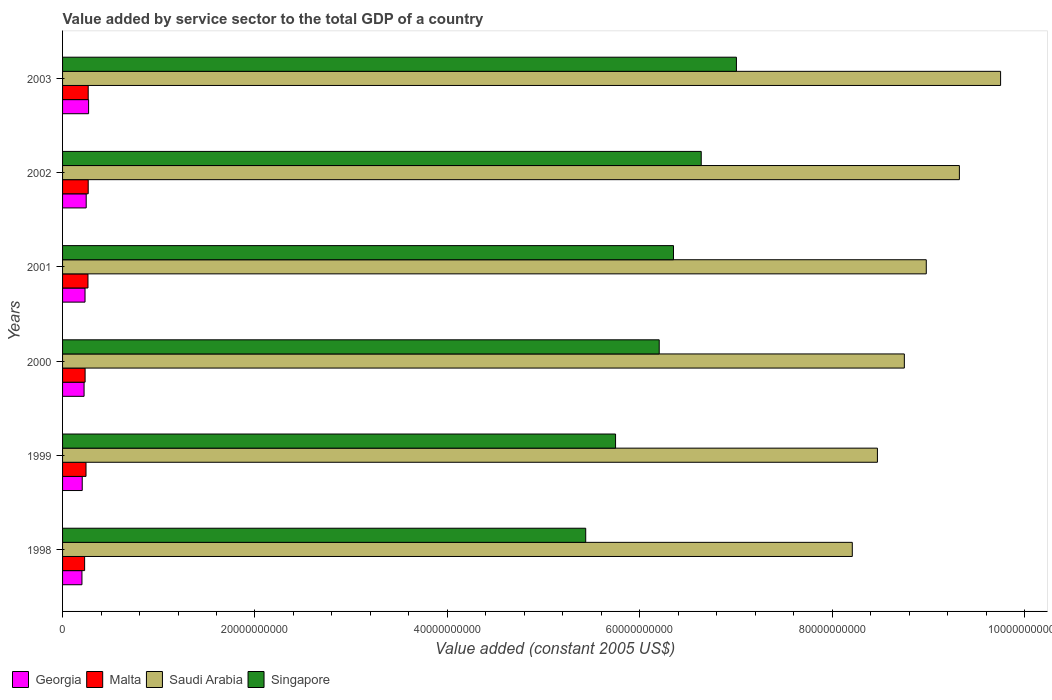How many groups of bars are there?
Your answer should be very brief. 6. Are the number of bars per tick equal to the number of legend labels?
Offer a very short reply. Yes. How many bars are there on the 1st tick from the top?
Provide a short and direct response. 4. How many bars are there on the 2nd tick from the bottom?
Offer a very short reply. 4. What is the label of the 1st group of bars from the top?
Offer a very short reply. 2003. In how many cases, is the number of bars for a given year not equal to the number of legend labels?
Offer a terse response. 0. What is the value added by service sector in Saudi Arabia in 1998?
Your answer should be compact. 8.21e+1. Across all years, what is the maximum value added by service sector in Saudi Arabia?
Make the answer very short. 9.75e+1. Across all years, what is the minimum value added by service sector in Singapore?
Provide a short and direct response. 5.44e+1. In which year was the value added by service sector in Malta minimum?
Offer a very short reply. 1998. What is the total value added by service sector in Malta in the graph?
Ensure brevity in your answer.  1.50e+1. What is the difference between the value added by service sector in Malta in 2002 and that in 2003?
Your answer should be very brief. 1.96e+05. What is the difference between the value added by service sector in Malta in 2003 and the value added by service sector in Georgia in 2002?
Your response must be concise. 2.07e+08. What is the average value added by service sector in Georgia per year?
Your answer should be compact. 2.30e+09. In the year 1999, what is the difference between the value added by service sector in Saudi Arabia and value added by service sector in Malta?
Your response must be concise. 8.23e+1. In how many years, is the value added by service sector in Malta greater than 48000000000 US$?
Give a very brief answer. 0. What is the ratio of the value added by service sector in Singapore in 2000 to that in 2003?
Provide a succinct answer. 0.89. Is the value added by service sector in Malta in 1999 less than that in 2001?
Give a very brief answer. Yes. What is the difference between the highest and the second highest value added by service sector in Georgia?
Provide a short and direct response. 2.49e+08. What is the difference between the highest and the lowest value added by service sector in Saudi Arabia?
Your answer should be very brief. 1.54e+1. In how many years, is the value added by service sector in Saudi Arabia greater than the average value added by service sector in Saudi Arabia taken over all years?
Offer a very short reply. 3. Is the sum of the value added by service sector in Singapore in 1998 and 2003 greater than the maximum value added by service sector in Saudi Arabia across all years?
Your response must be concise. Yes. What does the 4th bar from the top in 1999 represents?
Ensure brevity in your answer.  Georgia. What does the 2nd bar from the bottom in 2000 represents?
Offer a terse response. Malta. How many bars are there?
Your answer should be compact. 24. What is the difference between two consecutive major ticks on the X-axis?
Your answer should be compact. 2.00e+1. Are the values on the major ticks of X-axis written in scientific E-notation?
Offer a terse response. No. Does the graph contain any zero values?
Your answer should be very brief. No. Does the graph contain grids?
Offer a very short reply. No. Where does the legend appear in the graph?
Keep it short and to the point. Bottom left. What is the title of the graph?
Your answer should be compact. Value added by service sector to the total GDP of a country. What is the label or title of the X-axis?
Your answer should be compact. Value added (constant 2005 US$). What is the Value added (constant 2005 US$) in Georgia in 1998?
Provide a short and direct response. 2.02e+09. What is the Value added (constant 2005 US$) in Malta in 1998?
Offer a very short reply. 2.29e+09. What is the Value added (constant 2005 US$) in Saudi Arabia in 1998?
Provide a succinct answer. 8.21e+1. What is the Value added (constant 2005 US$) in Singapore in 1998?
Your response must be concise. 5.44e+1. What is the Value added (constant 2005 US$) of Georgia in 1999?
Your response must be concise. 2.04e+09. What is the Value added (constant 2005 US$) in Malta in 1999?
Your answer should be very brief. 2.44e+09. What is the Value added (constant 2005 US$) in Saudi Arabia in 1999?
Ensure brevity in your answer.  8.47e+1. What is the Value added (constant 2005 US$) in Singapore in 1999?
Make the answer very short. 5.75e+1. What is the Value added (constant 2005 US$) of Georgia in 2000?
Ensure brevity in your answer.  2.24e+09. What is the Value added (constant 2005 US$) in Malta in 2000?
Your answer should be very brief. 2.34e+09. What is the Value added (constant 2005 US$) in Saudi Arabia in 2000?
Your response must be concise. 8.75e+1. What is the Value added (constant 2005 US$) of Singapore in 2000?
Make the answer very short. 6.20e+1. What is the Value added (constant 2005 US$) of Georgia in 2001?
Offer a terse response. 2.33e+09. What is the Value added (constant 2005 US$) in Malta in 2001?
Keep it short and to the point. 2.64e+09. What is the Value added (constant 2005 US$) in Saudi Arabia in 2001?
Ensure brevity in your answer.  8.98e+1. What is the Value added (constant 2005 US$) in Singapore in 2001?
Offer a terse response. 6.35e+1. What is the Value added (constant 2005 US$) in Georgia in 2002?
Give a very brief answer. 2.46e+09. What is the Value added (constant 2005 US$) in Malta in 2002?
Provide a succinct answer. 2.66e+09. What is the Value added (constant 2005 US$) in Saudi Arabia in 2002?
Give a very brief answer. 9.32e+1. What is the Value added (constant 2005 US$) in Singapore in 2002?
Give a very brief answer. 6.64e+1. What is the Value added (constant 2005 US$) in Georgia in 2003?
Keep it short and to the point. 2.71e+09. What is the Value added (constant 2005 US$) of Malta in 2003?
Keep it short and to the point. 2.66e+09. What is the Value added (constant 2005 US$) in Saudi Arabia in 2003?
Provide a succinct answer. 9.75e+1. What is the Value added (constant 2005 US$) in Singapore in 2003?
Your answer should be compact. 7.00e+1. Across all years, what is the maximum Value added (constant 2005 US$) in Georgia?
Your answer should be compact. 2.71e+09. Across all years, what is the maximum Value added (constant 2005 US$) in Malta?
Provide a short and direct response. 2.66e+09. Across all years, what is the maximum Value added (constant 2005 US$) in Saudi Arabia?
Keep it short and to the point. 9.75e+1. Across all years, what is the maximum Value added (constant 2005 US$) in Singapore?
Ensure brevity in your answer.  7.00e+1. Across all years, what is the minimum Value added (constant 2005 US$) in Georgia?
Your answer should be compact. 2.02e+09. Across all years, what is the minimum Value added (constant 2005 US$) of Malta?
Give a very brief answer. 2.29e+09. Across all years, what is the minimum Value added (constant 2005 US$) in Saudi Arabia?
Your answer should be compact. 8.21e+1. Across all years, what is the minimum Value added (constant 2005 US$) of Singapore?
Ensure brevity in your answer.  5.44e+1. What is the total Value added (constant 2005 US$) of Georgia in the graph?
Offer a very short reply. 1.38e+1. What is the total Value added (constant 2005 US$) of Malta in the graph?
Provide a short and direct response. 1.50e+1. What is the total Value added (constant 2005 US$) of Saudi Arabia in the graph?
Offer a very short reply. 5.35e+11. What is the total Value added (constant 2005 US$) of Singapore in the graph?
Ensure brevity in your answer.  3.74e+11. What is the difference between the Value added (constant 2005 US$) of Georgia in 1998 and that in 1999?
Give a very brief answer. -2.80e+07. What is the difference between the Value added (constant 2005 US$) of Malta in 1998 and that in 1999?
Provide a succinct answer. -1.44e+08. What is the difference between the Value added (constant 2005 US$) of Saudi Arabia in 1998 and that in 1999?
Keep it short and to the point. -2.61e+09. What is the difference between the Value added (constant 2005 US$) in Singapore in 1998 and that in 1999?
Offer a very short reply. -3.10e+09. What is the difference between the Value added (constant 2005 US$) of Georgia in 1998 and that in 2000?
Provide a succinct answer. -2.20e+08. What is the difference between the Value added (constant 2005 US$) of Malta in 1998 and that in 2000?
Offer a very short reply. -4.99e+07. What is the difference between the Value added (constant 2005 US$) of Saudi Arabia in 1998 and that in 2000?
Make the answer very short. -5.41e+09. What is the difference between the Value added (constant 2005 US$) of Singapore in 1998 and that in 2000?
Offer a terse response. -7.64e+09. What is the difference between the Value added (constant 2005 US$) of Georgia in 1998 and that in 2001?
Keep it short and to the point. -3.19e+08. What is the difference between the Value added (constant 2005 US$) in Malta in 1998 and that in 2001?
Offer a very short reply. -3.48e+08. What is the difference between the Value added (constant 2005 US$) of Saudi Arabia in 1998 and that in 2001?
Offer a very short reply. -7.69e+09. What is the difference between the Value added (constant 2005 US$) of Singapore in 1998 and that in 2001?
Give a very brief answer. -9.12e+09. What is the difference between the Value added (constant 2005 US$) of Georgia in 1998 and that in 2002?
Provide a succinct answer. -4.41e+08. What is the difference between the Value added (constant 2005 US$) in Malta in 1998 and that in 2002?
Your answer should be very brief. -3.72e+08. What is the difference between the Value added (constant 2005 US$) of Saudi Arabia in 1998 and that in 2002?
Give a very brief answer. -1.11e+1. What is the difference between the Value added (constant 2005 US$) in Singapore in 1998 and that in 2002?
Offer a terse response. -1.20e+1. What is the difference between the Value added (constant 2005 US$) of Georgia in 1998 and that in 2003?
Give a very brief answer. -6.90e+08. What is the difference between the Value added (constant 2005 US$) of Malta in 1998 and that in 2003?
Keep it short and to the point. -3.71e+08. What is the difference between the Value added (constant 2005 US$) in Saudi Arabia in 1998 and that in 2003?
Your response must be concise. -1.54e+1. What is the difference between the Value added (constant 2005 US$) of Singapore in 1998 and that in 2003?
Provide a short and direct response. -1.57e+1. What is the difference between the Value added (constant 2005 US$) in Georgia in 1999 and that in 2000?
Make the answer very short. -1.92e+08. What is the difference between the Value added (constant 2005 US$) in Malta in 1999 and that in 2000?
Make the answer very short. 9.39e+07. What is the difference between the Value added (constant 2005 US$) in Saudi Arabia in 1999 and that in 2000?
Give a very brief answer. -2.80e+09. What is the difference between the Value added (constant 2005 US$) in Singapore in 1999 and that in 2000?
Provide a short and direct response. -4.54e+09. What is the difference between the Value added (constant 2005 US$) in Georgia in 1999 and that in 2001?
Your answer should be compact. -2.91e+08. What is the difference between the Value added (constant 2005 US$) of Malta in 1999 and that in 2001?
Give a very brief answer. -2.04e+08. What is the difference between the Value added (constant 2005 US$) of Saudi Arabia in 1999 and that in 2001?
Your response must be concise. -5.08e+09. What is the difference between the Value added (constant 2005 US$) in Singapore in 1999 and that in 2001?
Provide a succinct answer. -6.02e+09. What is the difference between the Value added (constant 2005 US$) in Georgia in 1999 and that in 2002?
Your answer should be compact. -4.13e+08. What is the difference between the Value added (constant 2005 US$) of Malta in 1999 and that in 2002?
Your answer should be compact. -2.28e+08. What is the difference between the Value added (constant 2005 US$) in Saudi Arabia in 1999 and that in 2002?
Offer a terse response. -8.52e+09. What is the difference between the Value added (constant 2005 US$) in Singapore in 1999 and that in 2002?
Make the answer very short. -8.90e+09. What is the difference between the Value added (constant 2005 US$) of Georgia in 1999 and that in 2003?
Your response must be concise. -6.62e+08. What is the difference between the Value added (constant 2005 US$) of Malta in 1999 and that in 2003?
Provide a short and direct response. -2.28e+08. What is the difference between the Value added (constant 2005 US$) in Saudi Arabia in 1999 and that in 2003?
Offer a terse response. -1.28e+1. What is the difference between the Value added (constant 2005 US$) in Singapore in 1999 and that in 2003?
Make the answer very short. -1.26e+1. What is the difference between the Value added (constant 2005 US$) in Georgia in 2000 and that in 2001?
Your answer should be very brief. -9.90e+07. What is the difference between the Value added (constant 2005 US$) in Malta in 2000 and that in 2001?
Make the answer very short. -2.98e+08. What is the difference between the Value added (constant 2005 US$) in Saudi Arabia in 2000 and that in 2001?
Provide a succinct answer. -2.28e+09. What is the difference between the Value added (constant 2005 US$) of Singapore in 2000 and that in 2001?
Ensure brevity in your answer.  -1.48e+09. What is the difference between the Value added (constant 2005 US$) of Georgia in 2000 and that in 2002?
Ensure brevity in your answer.  -2.22e+08. What is the difference between the Value added (constant 2005 US$) in Malta in 2000 and that in 2002?
Your response must be concise. -3.22e+08. What is the difference between the Value added (constant 2005 US$) in Saudi Arabia in 2000 and that in 2002?
Offer a very short reply. -5.72e+09. What is the difference between the Value added (constant 2005 US$) in Singapore in 2000 and that in 2002?
Offer a terse response. -4.37e+09. What is the difference between the Value added (constant 2005 US$) in Georgia in 2000 and that in 2003?
Your answer should be compact. -4.70e+08. What is the difference between the Value added (constant 2005 US$) of Malta in 2000 and that in 2003?
Your answer should be compact. -3.21e+08. What is the difference between the Value added (constant 2005 US$) in Saudi Arabia in 2000 and that in 2003?
Your response must be concise. -1.00e+1. What is the difference between the Value added (constant 2005 US$) in Singapore in 2000 and that in 2003?
Offer a very short reply. -8.02e+09. What is the difference between the Value added (constant 2005 US$) of Georgia in 2001 and that in 2002?
Give a very brief answer. -1.23e+08. What is the difference between the Value added (constant 2005 US$) of Malta in 2001 and that in 2002?
Provide a short and direct response. -2.40e+07. What is the difference between the Value added (constant 2005 US$) in Saudi Arabia in 2001 and that in 2002?
Your answer should be compact. -3.44e+09. What is the difference between the Value added (constant 2005 US$) in Singapore in 2001 and that in 2002?
Make the answer very short. -2.88e+09. What is the difference between the Value added (constant 2005 US$) in Georgia in 2001 and that in 2003?
Offer a very short reply. -3.71e+08. What is the difference between the Value added (constant 2005 US$) of Malta in 2001 and that in 2003?
Your answer should be very brief. -2.38e+07. What is the difference between the Value added (constant 2005 US$) of Saudi Arabia in 2001 and that in 2003?
Keep it short and to the point. -7.72e+09. What is the difference between the Value added (constant 2005 US$) of Singapore in 2001 and that in 2003?
Offer a very short reply. -6.54e+09. What is the difference between the Value added (constant 2005 US$) of Georgia in 2002 and that in 2003?
Your response must be concise. -2.49e+08. What is the difference between the Value added (constant 2005 US$) of Malta in 2002 and that in 2003?
Provide a short and direct response. 1.96e+05. What is the difference between the Value added (constant 2005 US$) of Saudi Arabia in 2002 and that in 2003?
Provide a succinct answer. -4.28e+09. What is the difference between the Value added (constant 2005 US$) in Singapore in 2002 and that in 2003?
Provide a succinct answer. -3.66e+09. What is the difference between the Value added (constant 2005 US$) in Georgia in 1998 and the Value added (constant 2005 US$) in Malta in 1999?
Your response must be concise. -4.21e+08. What is the difference between the Value added (constant 2005 US$) in Georgia in 1998 and the Value added (constant 2005 US$) in Saudi Arabia in 1999?
Offer a terse response. -8.27e+1. What is the difference between the Value added (constant 2005 US$) in Georgia in 1998 and the Value added (constant 2005 US$) in Singapore in 1999?
Give a very brief answer. -5.55e+1. What is the difference between the Value added (constant 2005 US$) of Malta in 1998 and the Value added (constant 2005 US$) of Saudi Arabia in 1999?
Your answer should be very brief. -8.24e+1. What is the difference between the Value added (constant 2005 US$) in Malta in 1998 and the Value added (constant 2005 US$) in Singapore in 1999?
Your answer should be very brief. -5.52e+1. What is the difference between the Value added (constant 2005 US$) in Saudi Arabia in 1998 and the Value added (constant 2005 US$) in Singapore in 1999?
Ensure brevity in your answer.  2.46e+1. What is the difference between the Value added (constant 2005 US$) in Georgia in 1998 and the Value added (constant 2005 US$) in Malta in 2000?
Give a very brief answer. -3.27e+08. What is the difference between the Value added (constant 2005 US$) of Georgia in 1998 and the Value added (constant 2005 US$) of Saudi Arabia in 2000?
Offer a terse response. -8.55e+1. What is the difference between the Value added (constant 2005 US$) in Georgia in 1998 and the Value added (constant 2005 US$) in Singapore in 2000?
Your answer should be very brief. -6.00e+1. What is the difference between the Value added (constant 2005 US$) of Malta in 1998 and the Value added (constant 2005 US$) of Saudi Arabia in 2000?
Give a very brief answer. -8.52e+1. What is the difference between the Value added (constant 2005 US$) of Malta in 1998 and the Value added (constant 2005 US$) of Singapore in 2000?
Keep it short and to the point. -5.97e+1. What is the difference between the Value added (constant 2005 US$) of Saudi Arabia in 1998 and the Value added (constant 2005 US$) of Singapore in 2000?
Provide a short and direct response. 2.01e+1. What is the difference between the Value added (constant 2005 US$) in Georgia in 1998 and the Value added (constant 2005 US$) in Malta in 2001?
Keep it short and to the point. -6.25e+08. What is the difference between the Value added (constant 2005 US$) in Georgia in 1998 and the Value added (constant 2005 US$) in Saudi Arabia in 2001?
Make the answer very short. -8.78e+1. What is the difference between the Value added (constant 2005 US$) in Georgia in 1998 and the Value added (constant 2005 US$) in Singapore in 2001?
Your response must be concise. -6.15e+1. What is the difference between the Value added (constant 2005 US$) in Malta in 1998 and the Value added (constant 2005 US$) in Saudi Arabia in 2001?
Provide a short and direct response. -8.75e+1. What is the difference between the Value added (constant 2005 US$) in Malta in 1998 and the Value added (constant 2005 US$) in Singapore in 2001?
Give a very brief answer. -6.12e+1. What is the difference between the Value added (constant 2005 US$) of Saudi Arabia in 1998 and the Value added (constant 2005 US$) of Singapore in 2001?
Your answer should be compact. 1.86e+1. What is the difference between the Value added (constant 2005 US$) of Georgia in 1998 and the Value added (constant 2005 US$) of Malta in 2002?
Provide a short and direct response. -6.49e+08. What is the difference between the Value added (constant 2005 US$) of Georgia in 1998 and the Value added (constant 2005 US$) of Saudi Arabia in 2002?
Give a very brief answer. -9.12e+1. What is the difference between the Value added (constant 2005 US$) of Georgia in 1998 and the Value added (constant 2005 US$) of Singapore in 2002?
Your answer should be compact. -6.44e+1. What is the difference between the Value added (constant 2005 US$) in Malta in 1998 and the Value added (constant 2005 US$) in Saudi Arabia in 2002?
Make the answer very short. -9.09e+1. What is the difference between the Value added (constant 2005 US$) of Malta in 1998 and the Value added (constant 2005 US$) of Singapore in 2002?
Make the answer very short. -6.41e+1. What is the difference between the Value added (constant 2005 US$) of Saudi Arabia in 1998 and the Value added (constant 2005 US$) of Singapore in 2002?
Give a very brief answer. 1.57e+1. What is the difference between the Value added (constant 2005 US$) of Georgia in 1998 and the Value added (constant 2005 US$) of Malta in 2003?
Offer a very short reply. -6.49e+08. What is the difference between the Value added (constant 2005 US$) of Georgia in 1998 and the Value added (constant 2005 US$) of Saudi Arabia in 2003?
Your answer should be very brief. -9.55e+1. What is the difference between the Value added (constant 2005 US$) in Georgia in 1998 and the Value added (constant 2005 US$) in Singapore in 2003?
Provide a succinct answer. -6.80e+1. What is the difference between the Value added (constant 2005 US$) in Malta in 1998 and the Value added (constant 2005 US$) in Saudi Arabia in 2003?
Give a very brief answer. -9.52e+1. What is the difference between the Value added (constant 2005 US$) of Malta in 1998 and the Value added (constant 2005 US$) of Singapore in 2003?
Keep it short and to the point. -6.78e+1. What is the difference between the Value added (constant 2005 US$) in Saudi Arabia in 1998 and the Value added (constant 2005 US$) in Singapore in 2003?
Your answer should be very brief. 1.20e+1. What is the difference between the Value added (constant 2005 US$) in Georgia in 1999 and the Value added (constant 2005 US$) in Malta in 2000?
Keep it short and to the point. -2.99e+08. What is the difference between the Value added (constant 2005 US$) of Georgia in 1999 and the Value added (constant 2005 US$) of Saudi Arabia in 2000?
Your answer should be compact. -8.55e+1. What is the difference between the Value added (constant 2005 US$) of Georgia in 1999 and the Value added (constant 2005 US$) of Singapore in 2000?
Your response must be concise. -6.00e+1. What is the difference between the Value added (constant 2005 US$) in Malta in 1999 and the Value added (constant 2005 US$) in Saudi Arabia in 2000?
Ensure brevity in your answer.  -8.51e+1. What is the difference between the Value added (constant 2005 US$) of Malta in 1999 and the Value added (constant 2005 US$) of Singapore in 2000?
Your response must be concise. -5.96e+1. What is the difference between the Value added (constant 2005 US$) in Saudi Arabia in 1999 and the Value added (constant 2005 US$) in Singapore in 2000?
Give a very brief answer. 2.27e+1. What is the difference between the Value added (constant 2005 US$) of Georgia in 1999 and the Value added (constant 2005 US$) of Malta in 2001?
Keep it short and to the point. -5.97e+08. What is the difference between the Value added (constant 2005 US$) of Georgia in 1999 and the Value added (constant 2005 US$) of Saudi Arabia in 2001?
Ensure brevity in your answer.  -8.77e+1. What is the difference between the Value added (constant 2005 US$) of Georgia in 1999 and the Value added (constant 2005 US$) of Singapore in 2001?
Ensure brevity in your answer.  -6.15e+1. What is the difference between the Value added (constant 2005 US$) in Malta in 1999 and the Value added (constant 2005 US$) in Saudi Arabia in 2001?
Ensure brevity in your answer.  -8.73e+1. What is the difference between the Value added (constant 2005 US$) of Malta in 1999 and the Value added (constant 2005 US$) of Singapore in 2001?
Offer a terse response. -6.11e+1. What is the difference between the Value added (constant 2005 US$) in Saudi Arabia in 1999 and the Value added (constant 2005 US$) in Singapore in 2001?
Keep it short and to the point. 2.12e+1. What is the difference between the Value added (constant 2005 US$) of Georgia in 1999 and the Value added (constant 2005 US$) of Malta in 2002?
Keep it short and to the point. -6.21e+08. What is the difference between the Value added (constant 2005 US$) in Georgia in 1999 and the Value added (constant 2005 US$) in Saudi Arabia in 2002?
Offer a very short reply. -9.12e+1. What is the difference between the Value added (constant 2005 US$) of Georgia in 1999 and the Value added (constant 2005 US$) of Singapore in 2002?
Your response must be concise. -6.43e+1. What is the difference between the Value added (constant 2005 US$) of Malta in 1999 and the Value added (constant 2005 US$) of Saudi Arabia in 2002?
Your answer should be very brief. -9.08e+1. What is the difference between the Value added (constant 2005 US$) in Malta in 1999 and the Value added (constant 2005 US$) in Singapore in 2002?
Your answer should be very brief. -6.39e+1. What is the difference between the Value added (constant 2005 US$) in Saudi Arabia in 1999 and the Value added (constant 2005 US$) in Singapore in 2002?
Give a very brief answer. 1.83e+1. What is the difference between the Value added (constant 2005 US$) of Georgia in 1999 and the Value added (constant 2005 US$) of Malta in 2003?
Provide a succinct answer. -6.21e+08. What is the difference between the Value added (constant 2005 US$) in Georgia in 1999 and the Value added (constant 2005 US$) in Saudi Arabia in 2003?
Offer a very short reply. -9.55e+1. What is the difference between the Value added (constant 2005 US$) in Georgia in 1999 and the Value added (constant 2005 US$) in Singapore in 2003?
Your response must be concise. -6.80e+1. What is the difference between the Value added (constant 2005 US$) of Malta in 1999 and the Value added (constant 2005 US$) of Saudi Arabia in 2003?
Your answer should be compact. -9.51e+1. What is the difference between the Value added (constant 2005 US$) in Malta in 1999 and the Value added (constant 2005 US$) in Singapore in 2003?
Ensure brevity in your answer.  -6.76e+1. What is the difference between the Value added (constant 2005 US$) of Saudi Arabia in 1999 and the Value added (constant 2005 US$) of Singapore in 2003?
Ensure brevity in your answer.  1.47e+1. What is the difference between the Value added (constant 2005 US$) in Georgia in 2000 and the Value added (constant 2005 US$) in Malta in 2001?
Provide a succinct answer. -4.05e+08. What is the difference between the Value added (constant 2005 US$) of Georgia in 2000 and the Value added (constant 2005 US$) of Saudi Arabia in 2001?
Your answer should be very brief. -8.75e+1. What is the difference between the Value added (constant 2005 US$) of Georgia in 2000 and the Value added (constant 2005 US$) of Singapore in 2001?
Your answer should be very brief. -6.13e+1. What is the difference between the Value added (constant 2005 US$) in Malta in 2000 and the Value added (constant 2005 US$) in Saudi Arabia in 2001?
Ensure brevity in your answer.  -8.74e+1. What is the difference between the Value added (constant 2005 US$) in Malta in 2000 and the Value added (constant 2005 US$) in Singapore in 2001?
Offer a terse response. -6.12e+1. What is the difference between the Value added (constant 2005 US$) in Saudi Arabia in 2000 and the Value added (constant 2005 US$) in Singapore in 2001?
Provide a short and direct response. 2.40e+1. What is the difference between the Value added (constant 2005 US$) in Georgia in 2000 and the Value added (constant 2005 US$) in Malta in 2002?
Your answer should be compact. -4.29e+08. What is the difference between the Value added (constant 2005 US$) in Georgia in 2000 and the Value added (constant 2005 US$) in Saudi Arabia in 2002?
Provide a succinct answer. -9.10e+1. What is the difference between the Value added (constant 2005 US$) in Georgia in 2000 and the Value added (constant 2005 US$) in Singapore in 2002?
Your answer should be compact. -6.42e+1. What is the difference between the Value added (constant 2005 US$) in Malta in 2000 and the Value added (constant 2005 US$) in Saudi Arabia in 2002?
Offer a terse response. -9.09e+1. What is the difference between the Value added (constant 2005 US$) in Malta in 2000 and the Value added (constant 2005 US$) in Singapore in 2002?
Ensure brevity in your answer.  -6.40e+1. What is the difference between the Value added (constant 2005 US$) in Saudi Arabia in 2000 and the Value added (constant 2005 US$) in Singapore in 2002?
Give a very brief answer. 2.11e+1. What is the difference between the Value added (constant 2005 US$) in Georgia in 2000 and the Value added (constant 2005 US$) in Malta in 2003?
Your response must be concise. -4.29e+08. What is the difference between the Value added (constant 2005 US$) of Georgia in 2000 and the Value added (constant 2005 US$) of Saudi Arabia in 2003?
Offer a very short reply. -9.53e+1. What is the difference between the Value added (constant 2005 US$) of Georgia in 2000 and the Value added (constant 2005 US$) of Singapore in 2003?
Your answer should be compact. -6.78e+1. What is the difference between the Value added (constant 2005 US$) in Malta in 2000 and the Value added (constant 2005 US$) in Saudi Arabia in 2003?
Keep it short and to the point. -9.52e+1. What is the difference between the Value added (constant 2005 US$) of Malta in 2000 and the Value added (constant 2005 US$) of Singapore in 2003?
Provide a short and direct response. -6.77e+1. What is the difference between the Value added (constant 2005 US$) of Saudi Arabia in 2000 and the Value added (constant 2005 US$) of Singapore in 2003?
Your response must be concise. 1.75e+1. What is the difference between the Value added (constant 2005 US$) in Georgia in 2001 and the Value added (constant 2005 US$) in Malta in 2002?
Your answer should be very brief. -3.30e+08. What is the difference between the Value added (constant 2005 US$) of Georgia in 2001 and the Value added (constant 2005 US$) of Saudi Arabia in 2002?
Ensure brevity in your answer.  -9.09e+1. What is the difference between the Value added (constant 2005 US$) in Georgia in 2001 and the Value added (constant 2005 US$) in Singapore in 2002?
Your answer should be compact. -6.41e+1. What is the difference between the Value added (constant 2005 US$) of Malta in 2001 and the Value added (constant 2005 US$) of Saudi Arabia in 2002?
Ensure brevity in your answer.  -9.06e+1. What is the difference between the Value added (constant 2005 US$) in Malta in 2001 and the Value added (constant 2005 US$) in Singapore in 2002?
Keep it short and to the point. -6.37e+1. What is the difference between the Value added (constant 2005 US$) of Saudi Arabia in 2001 and the Value added (constant 2005 US$) of Singapore in 2002?
Keep it short and to the point. 2.34e+1. What is the difference between the Value added (constant 2005 US$) in Georgia in 2001 and the Value added (constant 2005 US$) in Malta in 2003?
Provide a short and direct response. -3.30e+08. What is the difference between the Value added (constant 2005 US$) in Georgia in 2001 and the Value added (constant 2005 US$) in Saudi Arabia in 2003?
Your response must be concise. -9.52e+1. What is the difference between the Value added (constant 2005 US$) in Georgia in 2001 and the Value added (constant 2005 US$) in Singapore in 2003?
Your response must be concise. -6.77e+1. What is the difference between the Value added (constant 2005 US$) of Malta in 2001 and the Value added (constant 2005 US$) of Saudi Arabia in 2003?
Offer a very short reply. -9.49e+1. What is the difference between the Value added (constant 2005 US$) in Malta in 2001 and the Value added (constant 2005 US$) in Singapore in 2003?
Make the answer very short. -6.74e+1. What is the difference between the Value added (constant 2005 US$) of Saudi Arabia in 2001 and the Value added (constant 2005 US$) of Singapore in 2003?
Your answer should be very brief. 1.97e+1. What is the difference between the Value added (constant 2005 US$) of Georgia in 2002 and the Value added (constant 2005 US$) of Malta in 2003?
Offer a very short reply. -2.07e+08. What is the difference between the Value added (constant 2005 US$) of Georgia in 2002 and the Value added (constant 2005 US$) of Saudi Arabia in 2003?
Ensure brevity in your answer.  -9.50e+1. What is the difference between the Value added (constant 2005 US$) of Georgia in 2002 and the Value added (constant 2005 US$) of Singapore in 2003?
Your answer should be very brief. -6.76e+1. What is the difference between the Value added (constant 2005 US$) in Malta in 2002 and the Value added (constant 2005 US$) in Saudi Arabia in 2003?
Make the answer very short. -9.48e+1. What is the difference between the Value added (constant 2005 US$) in Malta in 2002 and the Value added (constant 2005 US$) in Singapore in 2003?
Make the answer very short. -6.74e+1. What is the difference between the Value added (constant 2005 US$) of Saudi Arabia in 2002 and the Value added (constant 2005 US$) of Singapore in 2003?
Your answer should be compact. 2.32e+1. What is the average Value added (constant 2005 US$) of Georgia per year?
Your response must be concise. 2.30e+09. What is the average Value added (constant 2005 US$) of Malta per year?
Your answer should be compact. 2.51e+09. What is the average Value added (constant 2005 US$) in Saudi Arabia per year?
Your answer should be compact. 8.91e+1. What is the average Value added (constant 2005 US$) of Singapore per year?
Your answer should be very brief. 6.23e+1. In the year 1998, what is the difference between the Value added (constant 2005 US$) of Georgia and Value added (constant 2005 US$) of Malta?
Make the answer very short. -2.77e+08. In the year 1998, what is the difference between the Value added (constant 2005 US$) of Georgia and Value added (constant 2005 US$) of Saudi Arabia?
Your response must be concise. -8.01e+1. In the year 1998, what is the difference between the Value added (constant 2005 US$) of Georgia and Value added (constant 2005 US$) of Singapore?
Your response must be concise. -5.24e+1. In the year 1998, what is the difference between the Value added (constant 2005 US$) in Malta and Value added (constant 2005 US$) in Saudi Arabia?
Offer a terse response. -7.98e+1. In the year 1998, what is the difference between the Value added (constant 2005 US$) of Malta and Value added (constant 2005 US$) of Singapore?
Give a very brief answer. -5.21e+1. In the year 1998, what is the difference between the Value added (constant 2005 US$) of Saudi Arabia and Value added (constant 2005 US$) of Singapore?
Give a very brief answer. 2.77e+1. In the year 1999, what is the difference between the Value added (constant 2005 US$) of Georgia and Value added (constant 2005 US$) of Malta?
Keep it short and to the point. -3.93e+08. In the year 1999, what is the difference between the Value added (constant 2005 US$) in Georgia and Value added (constant 2005 US$) in Saudi Arabia?
Provide a succinct answer. -8.27e+1. In the year 1999, what is the difference between the Value added (constant 2005 US$) in Georgia and Value added (constant 2005 US$) in Singapore?
Give a very brief answer. -5.54e+1. In the year 1999, what is the difference between the Value added (constant 2005 US$) in Malta and Value added (constant 2005 US$) in Saudi Arabia?
Your answer should be compact. -8.23e+1. In the year 1999, what is the difference between the Value added (constant 2005 US$) of Malta and Value added (constant 2005 US$) of Singapore?
Give a very brief answer. -5.50e+1. In the year 1999, what is the difference between the Value added (constant 2005 US$) of Saudi Arabia and Value added (constant 2005 US$) of Singapore?
Provide a short and direct response. 2.72e+1. In the year 2000, what is the difference between the Value added (constant 2005 US$) of Georgia and Value added (constant 2005 US$) of Malta?
Your answer should be very brief. -1.07e+08. In the year 2000, what is the difference between the Value added (constant 2005 US$) in Georgia and Value added (constant 2005 US$) in Saudi Arabia?
Provide a short and direct response. -8.53e+1. In the year 2000, what is the difference between the Value added (constant 2005 US$) of Georgia and Value added (constant 2005 US$) of Singapore?
Provide a succinct answer. -5.98e+1. In the year 2000, what is the difference between the Value added (constant 2005 US$) in Malta and Value added (constant 2005 US$) in Saudi Arabia?
Your answer should be compact. -8.52e+1. In the year 2000, what is the difference between the Value added (constant 2005 US$) of Malta and Value added (constant 2005 US$) of Singapore?
Your response must be concise. -5.97e+1. In the year 2000, what is the difference between the Value added (constant 2005 US$) of Saudi Arabia and Value added (constant 2005 US$) of Singapore?
Keep it short and to the point. 2.55e+1. In the year 2001, what is the difference between the Value added (constant 2005 US$) of Georgia and Value added (constant 2005 US$) of Malta?
Offer a terse response. -3.06e+08. In the year 2001, what is the difference between the Value added (constant 2005 US$) of Georgia and Value added (constant 2005 US$) of Saudi Arabia?
Provide a short and direct response. -8.74e+1. In the year 2001, what is the difference between the Value added (constant 2005 US$) in Georgia and Value added (constant 2005 US$) in Singapore?
Your answer should be very brief. -6.12e+1. In the year 2001, what is the difference between the Value added (constant 2005 US$) of Malta and Value added (constant 2005 US$) of Saudi Arabia?
Offer a terse response. -8.71e+1. In the year 2001, what is the difference between the Value added (constant 2005 US$) in Malta and Value added (constant 2005 US$) in Singapore?
Offer a very short reply. -6.09e+1. In the year 2001, what is the difference between the Value added (constant 2005 US$) in Saudi Arabia and Value added (constant 2005 US$) in Singapore?
Offer a terse response. 2.63e+1. In the year 2002, what is the difference between the Value added (constant 2005 US$) in Georgia and Value added (constant 2005 US$) in Malta?
Ensure brevity in your answer.  -2.07e+08. In the year 2002, what is the difference between the Value added (constant 2005 US$) of Georgia and Value added (constant 2005 US$) of Saudi Arabia?
Your answer should be very brief. -9.08e+1. In the year 2002, what is the difference between the Value added (constant 2005 US$) of Georgia and Value added (constant 2005 US$) of Singapore?
Offer a very short reply. -6.39e+1. In the year 2002, what is the difference between the Value added (constant 2005 US$) of Malta and Value added (constant 2005 US$) of Saudi Arabia?
Ensure brevity in your answer.  -9.06e+1. In the year 2002, what is the difference between the Value added (constant 2005 US$) of Malta and Value added (constant 2005 US$) of Singapore?
Make the answer very short. -6.37e+1. In the year 2002, what is the difference between the Value added (constant 2005 US$) of Saudi Arabia and Value added (constant 2005 US$) of Singapore?
Your answer should be very brief. 2.68e+1. In the year 2003, what is the difference between the Value added (constant 2005 US$) in Georgia and Value added (constant 2005 US$) in Malta?
Ensure brevity in your answer.  4.14e+07. In the year 2003, what is the difference between the Value added (constant 2005 US$) of Georgia and Value added (constant 2005 US$) of Saudi Arabia?
Offer a terse response. -9.48e+1. In the year 2003, what is the difference between the Value added (constant 2005 US$) of Georgia and Value added (constant 2005 US$) of Singapore?
Ensure brevity in your answer.  -6.73e+1. In the year 2003, what is the difference between the Value added (constant 2005 US$) of Malta and Value added (constant 2005 US$) of Saudi Arabia?
Make the answer very short. -9.48e+1. In the year 2003, what is the difference between the Value added (constant 2005 US$) of Malta and Value added (constant 2005 US$) of Singapore?
Keep it short and to the point. -6.74e+1. In the year 2003, what is the difference between the Value added (constant 2005 US$) in Saudi Arabia and Value added (constant 2005 US$) in Singapore?
Provide a short and direct response. 2.75e+1. What is the ratio of the Value added (constant 2005 US$) of Georgia in 1998 to that in 1999?
Ensure brevity in your answer.  0.99. What is the ratio of the Value added (constant 2005 US$) in Malta in 1998 to that in 1999?
Ensure brevity in your answer.  0.94. What is the ratio of the Value added (constant 2005 US$) of Saudi Arabia in 1998 to that in 1999?
Your response must be concise. 0.97. What is the ratio of the Value added (constant 2005 US$) in Singapore in 1998 to that in 1999?
Offer a terse response. 0.95. What is the ratio of the Value added (constant 2005 US$) in Georgia in 1998 to that in 2000?
Offer a terse response. 0.9. What is the ratio of the Value added (constant 2005 US$) of Malta in 1998 to that in 2000?
Provide a short and direct response. 0.98. What is the ratio of the Value added (constant 2005 US$) in Saudi Arabia in 1998 to that in 2000?
Keep it short and to the point. 0.94. What is the ratio of the Value added (constant 2005 US$) of Singapore in 1998 to that in 2000?
Keep it short and to the point. 0.88. What is the ratio of the Value added (constant 2005 US$) in Georgia in 1998 to that in 2001?
Offer a very short reply. 0.86. What is the ratio of the Value added (constant 2005 US$) of Malta in 1998 to that in 2001?
Provide a succinct answer. 0.87. What is the ratio of the Value added (constant 2005 US$) of Saudi Arabia in 1998 to that in 2001?
Provide a succinct answer. 0.91. What is the ratio of the Value added (constant 2005 US$) of Singapore in 1998 to that in 2001?
Keep it short and to the point. 0.86. What is the ratio of the Value added (constant 2005 US$) in Georgia in 1998 to that in 2002?
Your response must be concise. 0.82. What is the ratio of the Value added (constant 2005 US$) of Malta in 1998 to that in 2002?
Make the answer very short. 0.86. What is the ratio of the Value added (constant 2005 US$) in Saudi Arabia in 1998 to that in 2002?
Your answer should be compact. 0.88. What is the ratio of the Value added (constant 2005 US$) of Singapore in 1998 to that in 2002?
Your answer should be very brief. 0.82. What is the ratio of the Value added (constant 2005 US$) of Georgia in 1998 to that in 2003?
Offer a terse response. 0.74. What is the ratio of the Value added (constant 2005 US$) in Malta in 1998 to that in 2003?
Give a very brief answer. 0.86. What is the ratio of the Value added (constant 2005 US$) of Saudi Arabia in 1998 to that in 2003?
Your answer should be very brief. 0.84. What is the ratio of the Value added (constant 2005 US$) in Singapore in 1998 to that in 2003?
Ensure brevity in your answer.  0.78. What is the ratio of the Value added (constant 2005 US$) in Georgia in 1999 to that in 2000?
Your answer should be compact. 0.91. What is the ratio of the Value added (constant 2005 US$) of Malta in 1999 to that in 2000?
Offer a terse response. 1.04. What is the ratio of the Value added (constant 2005 US$) in Singapore in 1999 to that in 2000?
Make the answer very short. 0.93. What is the ratio of the Value added (constant 2005 US$) in Georgia in 1999 to that in 2001?
Keep it short and to the point. 0.88. What is the ratio of the Value added (constant 2005 US$) in Malta in 1999 to that in 2001?
Offer a terse response. 0.92. What is the ratio of the Value added (constant 2005 US$) of Saudi Arabia in 1999 to that in 2001?
Give a very brief answer. 0.94. What is the ratio of the Value added (constant 2005 US$) of Singapore in 1999 to that in 2001?
Offer a terse response. 0.91. What is the ratio of the Value added (constant 2005 US$) of Georgia in 1999 to that in 2002?
Keep it short and to the point. 0.83. What is the ratio of the Value added (constant 2005 US$) in Malta in 1999 to that in 2002?
Provide a succinct answer. 0.91. What is the ratio of the Value added (constant 2005 US$) of Saudi Arabia in 1999 to that in 2002?
Provide a succinct answer. 0.91. What is the ratio of the Value added (constant 2005 US$) of Singapore in 1999 to that in 2002?
Offer a very short reply. 0.87. What is the ratio of the Value added (constant 2005 US$) in Georgia in 1999 to that in 2003?
Ensure brevity in your answer.  0.76. What is the ratio of the Value added (constant 2005 US$) in Malta in 1999 to that in 2003?
Your response must be concise. 0.91. What is the ratio of the Value added (constant 2005 US$) of Saudi Arabia in 1999 to that in 2003?
Your answer should be very brief. 0.87. What is the ratio of the Value added (constant 2005 US$) in Singapore in 1999 to that in 2003?
Provide a succinct answer. 0.82. What is the ratio of the Value added (constant 2005 US$) of Georgia in 2000 to that in 2001?
Your response must be concise. 0.96. What is the ratio of the Value added (constant 2005 US$) of Malta in 2000 to that in 2001?
Your response must be concise. 0.89. What is the ratio of the Value added (constant 2005 US$) of Saudi Arabia in 2000 to that in 2001?
Your answer should be compact. 0.97. What is the ratio of the Value added (constant 2005 US$) of Singapore in 2000 to that in 2001?
Your answer should be very brief. 0.98. What is the ratio of the Value added (constant 2005 US$) in Georgia in 2000 to that in 2002?
Make the answer very short. 0.91. What is the ratio of the Value added (constant 2005 US$) in Malta in 2000 to that in 2002?
Ensure brevity in your answer.  0.88. What is the ratio of the Value added (constant 2005 US$) in Saudi Arabia in 2000 to that in 2002?
Offer a terse response. 0.94. What is the ratio of the Value added (constant 2005 US$) in Singapore in 2000 to that in 2002?
Your response must be concise. 0.93. What is the ratio of the Value added (constant 2005 US$) of Georgia in 2000 to that in 2003?
Your response must be concise. 0.83. What is the ratio of the Value added (constant 2005 US$) of Malta in 2000 to that in 2003?
Provide a succinct answer. 0.88. What is the ratio of the Value added (constant 2005 US$) in Saudi Arabia in 2000 to that in 2003?
Your answer should be compact. 0.9. What is the ratio of the Value added (constant 2005 US$) of Singapore in 2000 to that in 2003?
Make the answer very short. 0.89. What is the ratio of the Value added (constant 2005 US$) in Georgia in 2001 to that in 2002?
Your answer should be very brief. 0.95. What is the ratio of the Value added (constant 2005 US$) of Malta in 2001 to that in 2002?
Give a very brief answer. 0.99. What is the ratio of the Value added (constant 2005 US$) in Saudi Arabia in 2001 to that in 2002?
Your answer should be compact. 0.96. What is the ratio of the Value added (constant 2005 US$) in Singapore in 2001 to that in 2002?
Your response must be concise. 0.96. What is the ratio of the Value added (constant 2005 US$) in Georgia in 2001 to that in 2003?
Provide a short and direct response. 0.86. What is the ratio of the Value added (constant 2005 US$) in Saudi Arabia in 2001 to that in 2003?
Keep it short and to the point. 0.92. What is the ratio of the Value added (constant 2005 US$) of Singapore in 2001 to that in 2003?
Provide a short and direct response. 0.91. What is the ratio of the Value added (constant 2005 US$) of Georgia in 2002 to that in 2003?
Offer a terse response. 0.91. What is the ratio of the Value added (constant 2005 US$) of Saudi Arabia in 2002 to that in 2003?
Give a very brief answer. 0.96. What is the ratio of the Value added (constant 2005 US$) of Singapore in 2002 to that in 2003?
Your answer should be compact. 0.95. What is the difference between the highest and the second highest Value added (constant 2005 US$) of Georgia?
Your answer should be compact. 2.49e+08. What is the difference between the highest and the second highest Value added (constant 2005 US$) of Malta?
Your answer should be very brief. 1.96e+05. What is the difference between the highest and the second highest Value added (constant 2005 US$) in Saudi Arabia?
Offer a terse response. 4.28e+09. What is the difference between the highest and the second highest Value added (constant 2005 US$) of Singapore?
Provide a succinct answer. 3.66e+09. What is the difference between the highest and the lowest Value added (constant 2005 US$) in Georgia?
Ensure brevity in your answer.  6.90e+08. What is the difference between the highest and the lowest Value added (constant 2005 US$) of Malta?
Ensure brevity in your answer.  3.72e+08. What is the difference between the highest and the lowest Value added (constant 2005 US$) of Saudi Arabia?
Ensure brevity in your answer.  1.54e+1. What is the difference between the highest and the lowest Value added (constant 2005 US$) in Singapore?
Ensure brevity in your answer.  1.57e+1. 